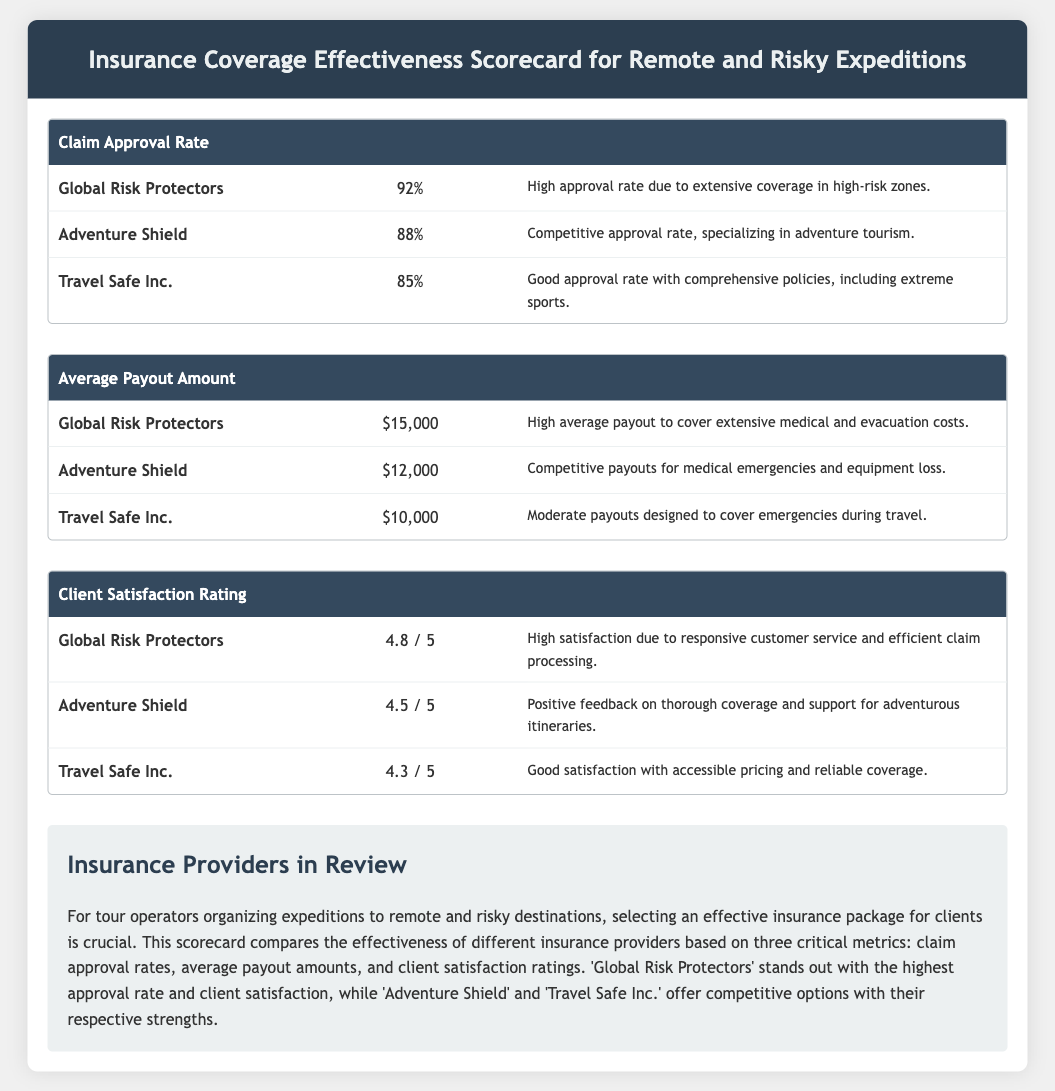What is the highest claim approval rate? The highest claim approval rate among the providers in the document is noted for 'Global Risk Protectors', which is provided as 92%.
Answer: 92% What is the average payout amount for Travel Safe Inc.? The document states that the average payout amount for 'Travel Safe Inc.' is $10,000.
Answer: $10,000 Which insurance provider has a client satisfaction rating of 4.5 / 5? According to the scorecard, 'Adventure Shield' has a client satisfaction rating of 4.5 / 5.
Answer: Adventure Shield What is the average payout amount for Global Risk Protectors? The average payout amount listed for 'Global Risk Protectors' is $15,000, as noted in the scorecard.
Answer: $15,000 Which provider has the lowest claim approval rate? The lowest claim approval rate among the listed providers is for 'Travel Safe Inc.', at 85%.
Answer: Travel Safe Inc What is the client satisfaction rating for Adventure Shield? The document indicates that 'Adventure Shield' has a client satisfaction rating of 4.5 / 5.
Answer: 4.5 / 5 Which provider provides the highest average payout amount? The scorecard shows that 'Global Risk Protectors' provides the highest average payout amount of $15,000.
Answer: $15,000 What rating does Travel Safe Inc. receive in client satisfaction? The client satisfaction rating for 'Travel Safe Inc.' as mentioned in the document is 4.3 / 5.
Answer: 4.3 / 5 Which insurance provider specializes in adventure tourism? The document describes 'Adventure Shield' as specializing in adventure tourism.
Answer: Adventure Shield 